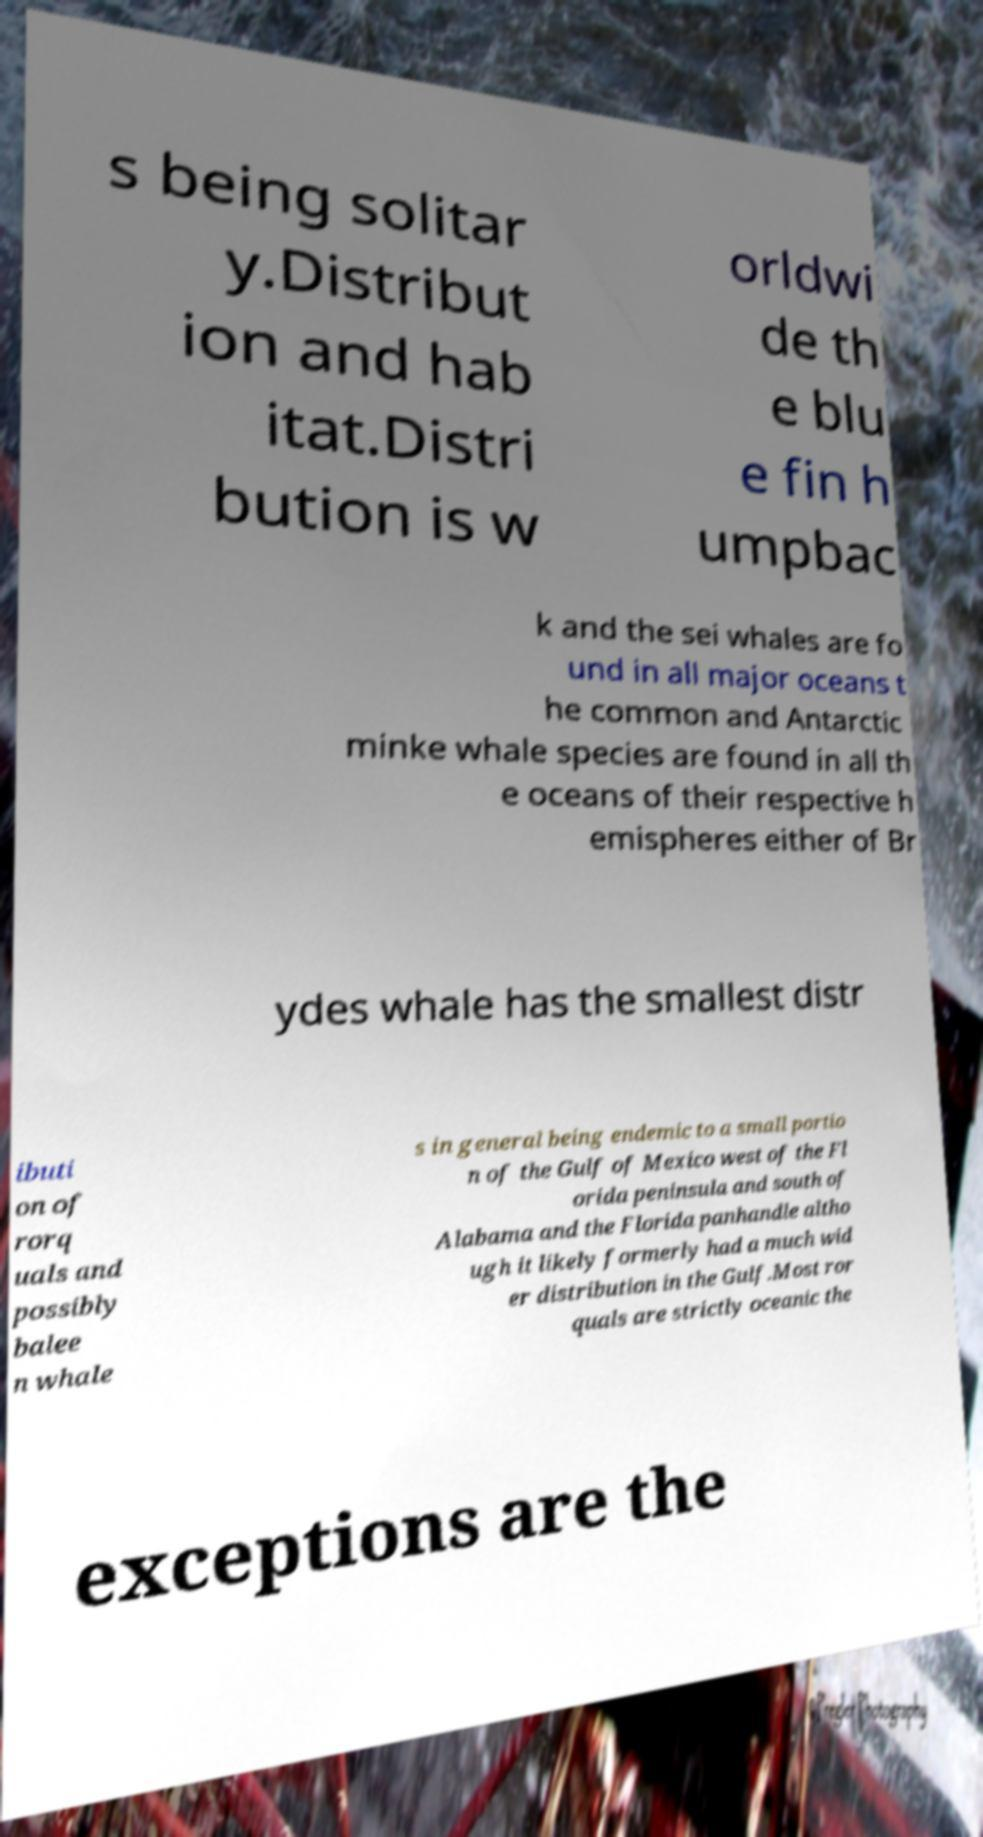Could you extract and type out the text from this image? s being solitar y.Distribut ion and hab itat.Distri bution is w orldwi de th e blu e fin h umpbac k and the sei whales are fo und in all major oceans t he common and Antarctic minke whale species are found in all th e oceans of their respective h emispheres either of Br ydes whale has the smallest distr ibuti on of rorq uals and possibly balee n whale s in general being endemic to a small portio n of the Gulf of Mexico west of the Fl orida peninsula and south of Alabama and the Florida panhandle altho ugh it likely formerly had a much wid er distribution in the Gulf.Most ror quals are strictly oceanic the exceptions are the 